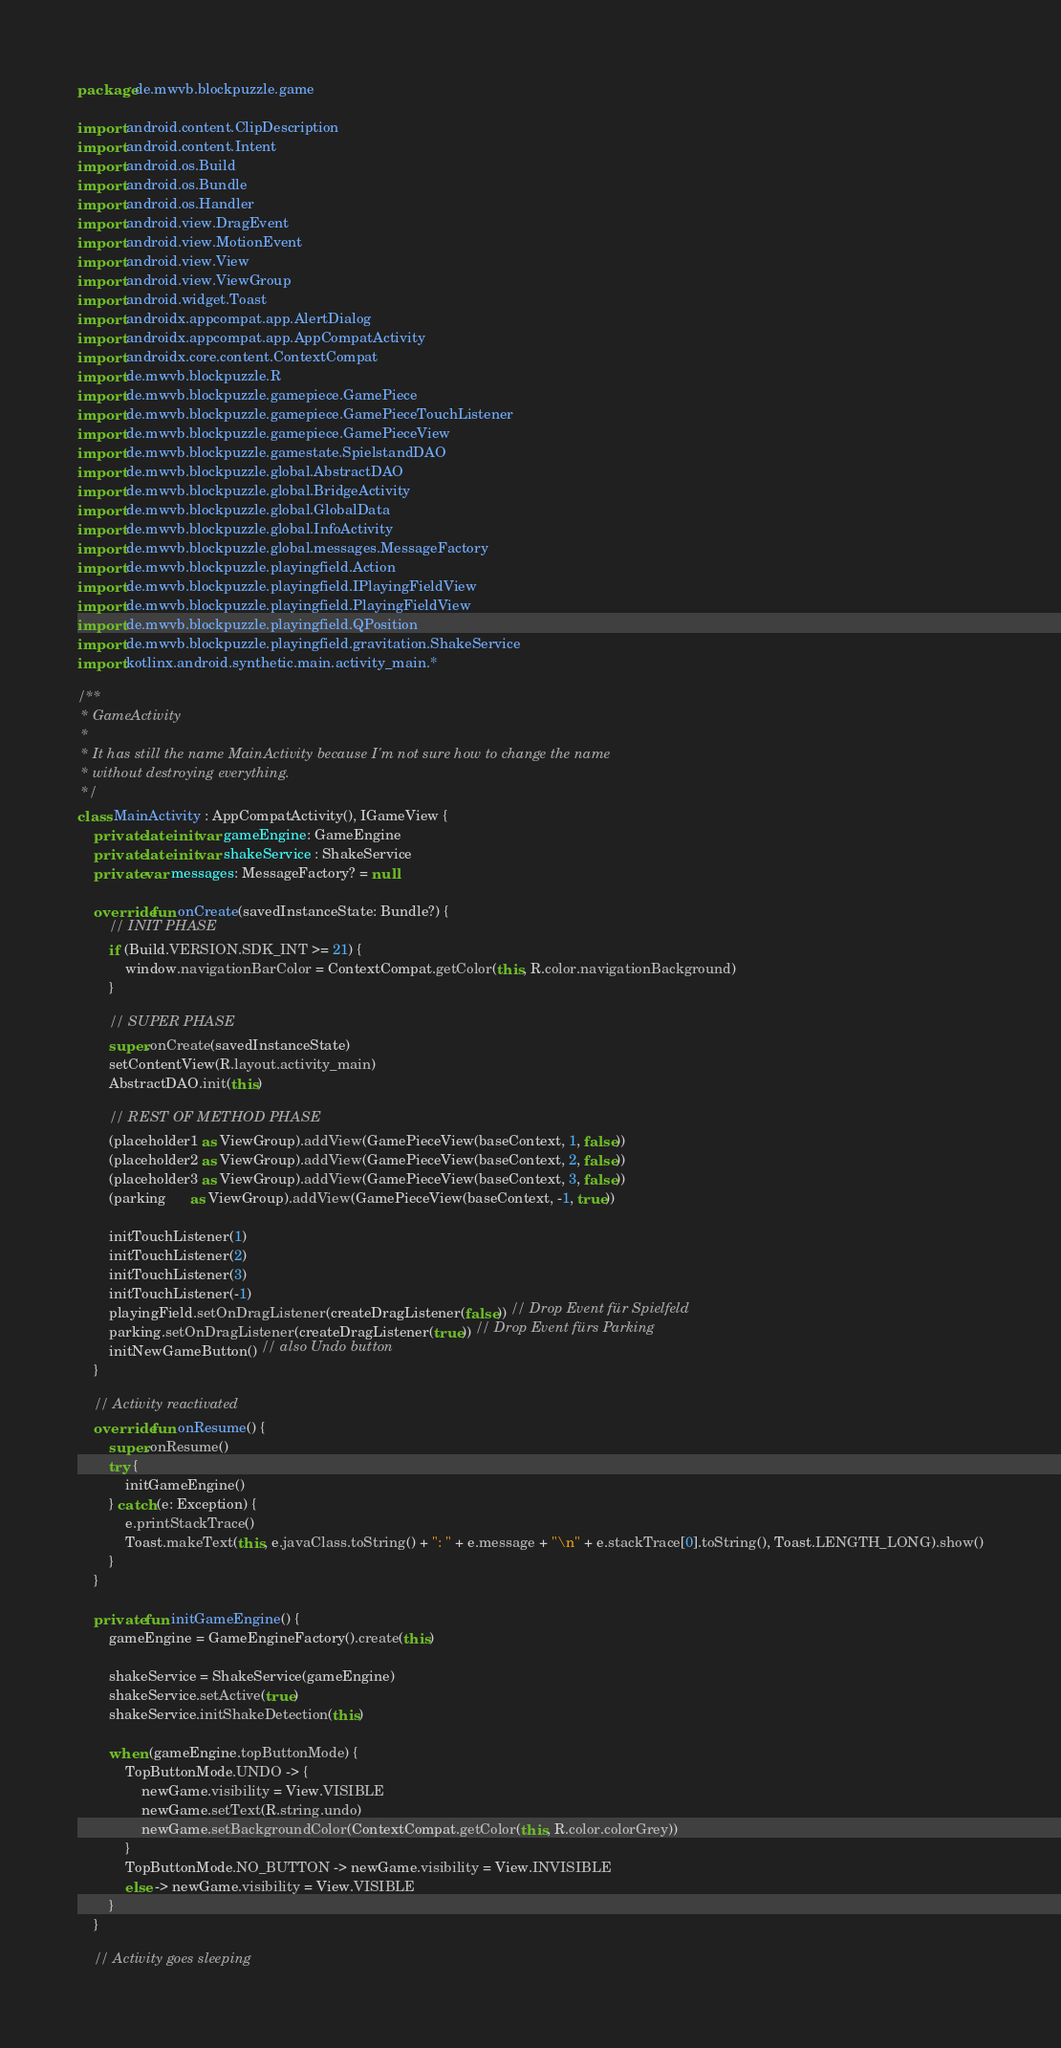Convert code to text. <code><loc_0><loc_0><loc_500><loc_500><_Kotlin_>package de.mwvb.blockpuzzle.game

import android.content.ClipDescription
import android.content.Intent
import android.os.Build
import android.os.Bundle
import android.os.Handler
import android.view.DragEvent
import android.view.MotionEvent
import android.view.View
import android.view.ViewGroup
import android.widget.Toast
import androidx.appcompat.app.AlertDialog
import androidx.appcompat.app.AppCompatActivity
import androidx.core.content.ContextCompat
import de.mwvb.blockpuzzle.R
import de.mwvb.blockpuzzle.gamepiece.GamePiece
import de.mwvb.blockpuzzle.gamepiece.GamePieceTouchListener
import de.mwvb.blockpuzzle.gamepiece.GamePieceView
import de.mwvb.blockpuzzle.gamestate.SpielstandDAO
import de.mwvb.blockpuzzle.global.AbstractDAO
import de.mwvb.blockpuzzle.global.BridgeActivity
import de.mwvb.blockpuzzle.global.GlobalData
import de.mwvb.blockpuzzle.global.InfoActivity
import de.mwvb.blockpuzzle.global.messages.MessageFactory
import de.mwvb.blockpuzzle.playingfield.Action
import de.mwvb.blockpuzzle.playingfield.IPlayingFieldView
import de.mwvb.blockpuzzle.playingfield.PlayingFieldView
import de.mwvb.blockpuzzle.playingfield.QPosition
import de.mwvb.blockpuzzle.playingfield.gravitation.ShakeService
import kotlinx.android.synthetic.main.activity_main.*

/**
 * GameActivity
 *
 * It has still the name MainActivity because I'm not sure how to change the name
 * without destroying everything.
 */
class MainActivity : AppCompatActivity(), IGameView {
    private lateinit var gameEngine: GameEngine
    private lateinit var shakeService : ShakeService
    private var messages: MessageFactory? = null

    override fun onCreate(savedInstanceState: Bundle?) {
        // INIT PHASE
        if (Build.VERSION.SDK_INT >= 21) {
            window.navigationBarColor = ContextCompat.getColor(this, R.color.navigationBackground)
        }

        // SUPER PHASE
        super.onCreate(savedInstanceState)
        setContentView(R.layout.activity_main)
        AbstractDAO.init(this)

        // REST OF METHOD PHASE
        (placeholder1 as ViewGroup).addView(GamePieceView(baseContext, 1, false))
        (placeholder2 as ViewGroup).addView(GamePieceView(baseContext, 2, false))
        (placeholder3 as ViewGroup).addView(GamePieceView(baseContext, 3, false))
        (parking      as ViewGroup).addView(GamePieceView(baseContext, -1, true))

        initTouchListener(1)
        initTouchListener(2)
        initTouchListener(3)
        initTouchListener(-1)
        playingField.setOnDragListener(createDragListener(false)) // Drop Event für Spielfeld
        parking.setOnDragListener(createDragListener(true)) // Drop Event fürs Parking
        initNewGameButton() // also Undo button
    }

    // Activity reactivated
    override fun onResume() {
        super.onResume()
        try {
            initGameEngine()
        } catch (e: Exception) {
            e.printStackTrace()
            Toast.makeText(this, e.javaClass.toString() + ": " + e.message + "\n" + e.stackTrace[0].toString(), Toast.LENGTH_LONG).show()
        }
    }

    private fun initGameEngine() {
        gameEngine = GameEngineFactory().create(this)

        shakeService = ShakeService(gameEngine)
        shakeService.setActive(true)
        shakeService.initShakeDetection(this)

        when (gameEngine.topButtonMode) {
            TopButtonMode.UNDO -> {
                newGame.visibility = View.VISIBLE
                newGame.setText(R.string.undo)
                newGame.setBackgroundColor(ContextCompat.getColor(this, R.color.colorGrey))
            }
            TopButtonMode.NO_BUTTON -> newGame.visibility = View.INVISIBLE
            else -> newGame.visibility = View.VISIBLE
        }
    }

    // Activity goes sleeping</code> 